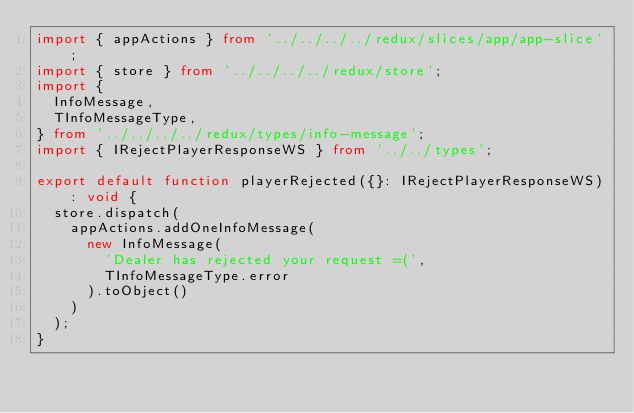Convert code to text. <code><loc_0><loc_0><loc_500><loc_500><_TypeScript_>import { appActions } from '../../../../redux/slices/app/app-slice';
import { store } from '../../../../redux/store';
import {
  InfoMessage,
  TInfoMessageType,
} from '../../../../redux/types/info-message';
import { IRejectPlayerResponseWS } from '../../types';

export default function playerRejected({}: IRejectPlayerResponseWS): void {
  store.dispatch(
    appActions.addOneInfoMessage(
      new InfoMessage(
        'Dealer has rejected your request =(',
        TInfoMessageType.error
      ).toObject()
    )
  );
}
</code> 